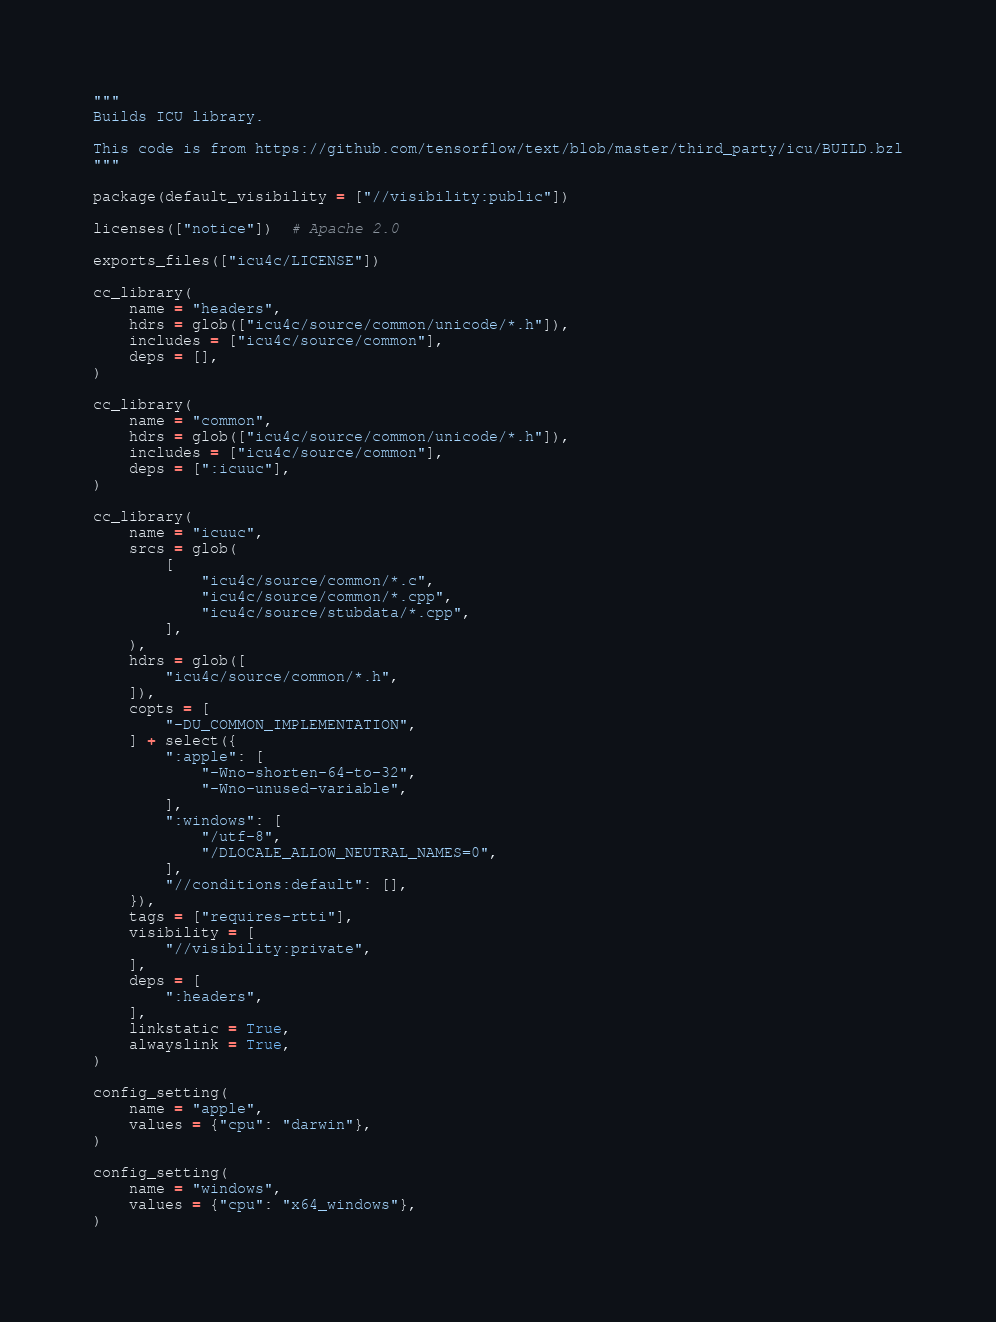<code> <loc_0><loc_0><loc_500><loc_500><_Python_>"""
Builds ICU library.

This code is from https://github.com/tensorflow/text/blob/master/third_party/icu/BUILD.bzl
"""

package(default_visibility = ["//visibility:public"])

licenses(["notice"])  # Apache 2.0

exports_files(["icu4c/LICENSE"])

cc_library(
    name = "headers",
    hdrs = glob(["icu4c/source/common/unicode/*.h"]),
    includes = ["icu4c/source/common"],
    deps = [],
)

cc_library(
    name = "common",
    hdrs = glob(["icu4c/source/common/unicode/*.h"]),
    includes = ["icu4c/source/common"],
    deps = [":icuuc"],
)

cc_library(
    name = "icuuc",
    srcs = glob(
        [
            "icu4c/source/common/*.c",
            "icu4c/source/common/*.cpp",
            "icu4c/source/stubdata/*.cpp",
        ],
    ),
    hdrs = glob([
        "icu4c/source/common/*.h",
    ]),
    copts = [
        "-DU_COMMON_IMPLEMENTATION",
    ] + select({
        ":apple": [
            "-Wno-shorten-64-to-32",
            "-Wno-unused-variable",
        ],
        ":windows": [
            "/utf-8",
            "/DLOCALE_ALLOW_NEUTRAL_NAMES=0",
        ],
        "//conditions:default": [],
    }),
    tags = ["requires-rtti"],
    visibility = [
        "//visibility:private",
    ],
    deps = [
        ":headers",
    ],
    linkstatic = True,
    alwayslink = True,
)

config_setting(
    name = "apple",
    values = {"cpu": "darwin"},
)

config_setting(
    name = "windows",
    values = {"cpu": "x64_windows"},
)
</code> 